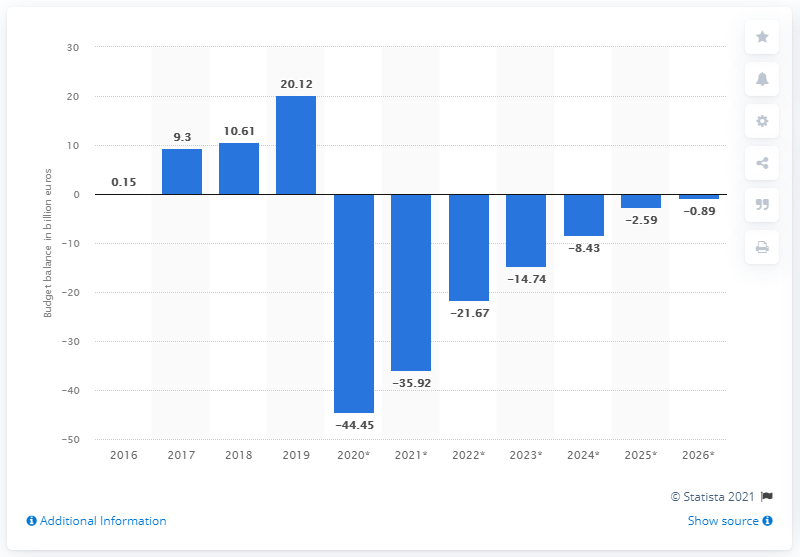Give some essential details in this illustration. In 2019, the state surplus of the Netherlands was 20.12. 